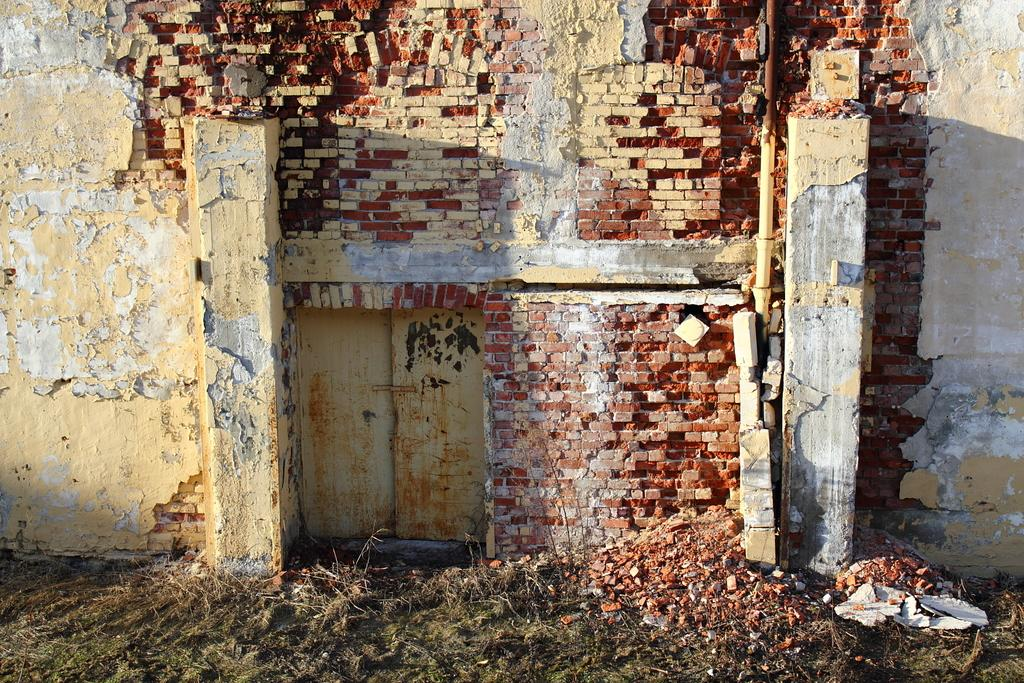What can be seen in the background of the image? There is a wall and a pipe in the background of the image. What is visible at the bottom portion of the image? The ground is visible at the bottom portion of the image. How would you describe the condition of the ground? The ground appears to be messy. What type of stamp can be seen on the map in the image? There is no map or stamp present in the image. What decision is being made by the person in the image? There is no person or decision-making process depicted in the image. 